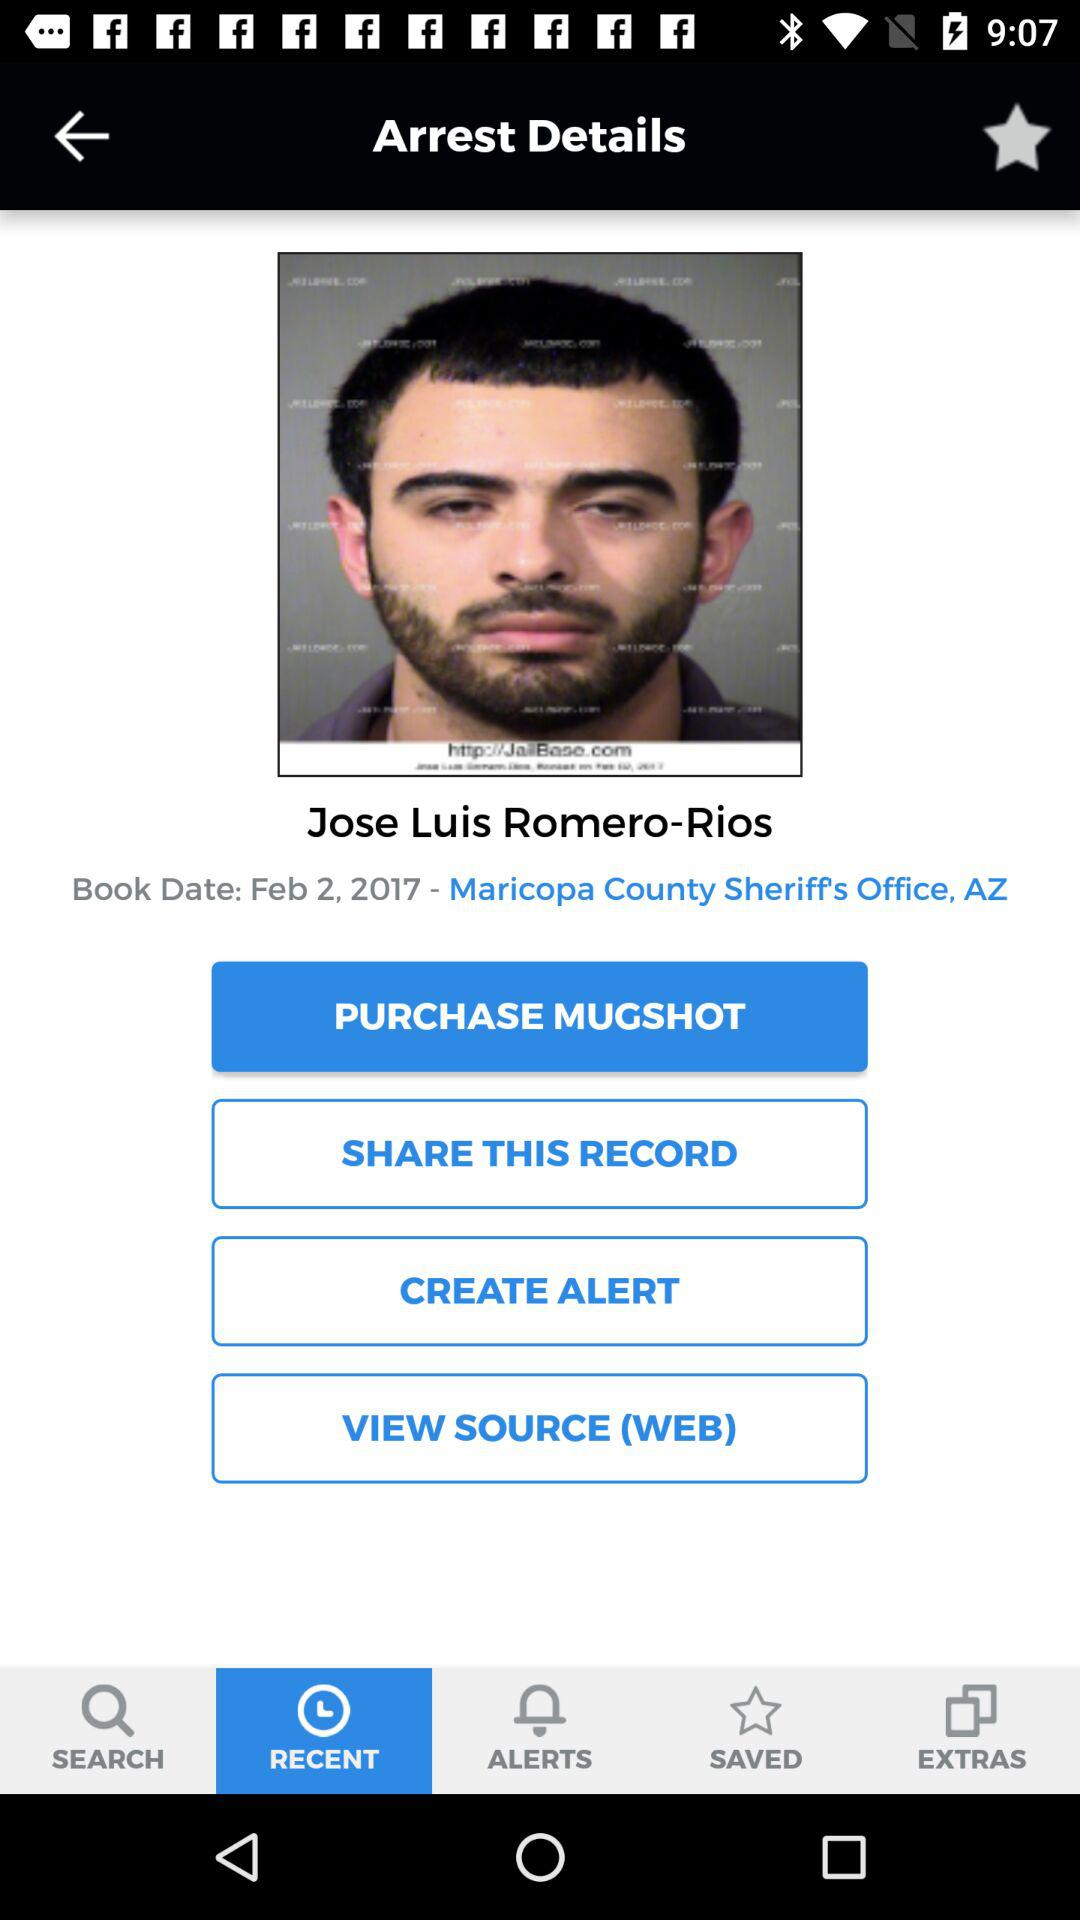How much does the mugshot cost?
When the provided information is insufficient, respond with <no answer>. <no answer> 